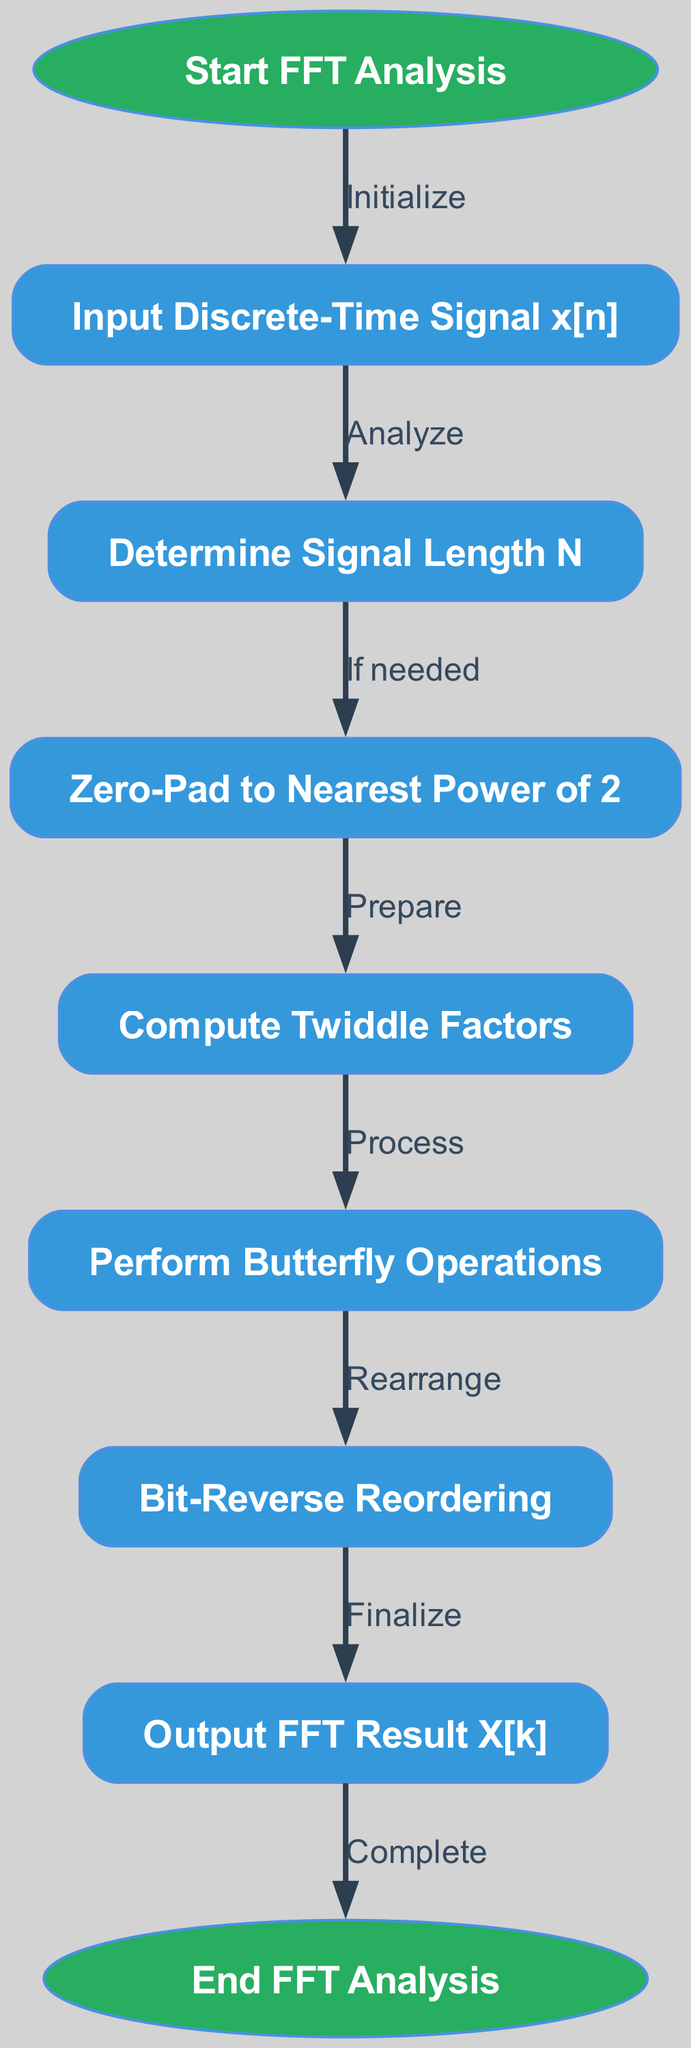What is the first step in the FFT analysis process? The flowchart starts with the "Start FFT Analysis" node, indicating that this is the initial step in the process.
Answer: Start FFT Analysis How many nodes are present in the diagram? By counting each unique node listed in the data, we find there are 9 nodes that represent different steps in the FFT analysis.
Answer: 9 What is done after determining the signal length? The flowchart indicates that the next step after determining the signal length N is to "Zero-Pad to Nearest Power of 2".
Answer: Zero-Pad to Nearest Power of 2 What operation follows the computation of the twiddle factors? After the "Compute Twiddle Factors" step, the next operation in the diagram is "Perform Butterfly Operations".
Answer: Perform Butterfly Operations Which step comes before outputting the FFT result? According to the flowchart, the step that comes immediately before outputting the FFT result is "Bit-Reverse Reordering".
Answer: Bit-Reverse Reordering What is the role of the node that represents “Input Discrete-Time Signal x[n]”? This node signifies the initial action where the discrete-time signal is received as input to begin the FFT analysis process.
Answer: Input Discrete-Time Signal x[n] Is zero-padding always necessary in this process? The flowchart indicates that zero-padding is conditional with an "If needed" statement following the "Determine Signal Length N" step, suggesting it may not always be necessary.
Answer: If needed In which section of the flowchart is the "Compute Twiddle Factors" step located? The "Compute Twiddle Factors" step is positioned after the "Zero-Pad to Nearest Power of 2" step and before the "Perform Butterfly Operations" step in the flowchart.
Answer: After Zero-Pad to Nearest Power of 2 What does the final node signify in the flowchart? The final node labeled "End FFT Analysis" indicates the completion of the process, marking where the analysis concludes.
Answer: End FFT Analysis 